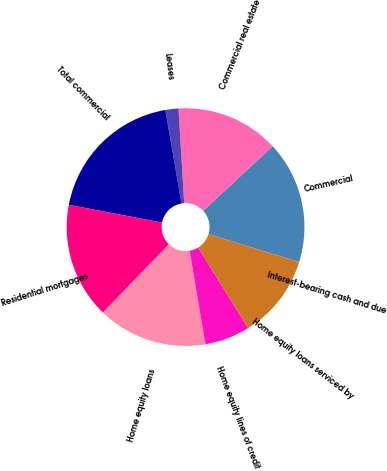<chart> <loc_0><loc_0><loc_500><loc_500><pie_chart><fcel>Interest-bearing cash and due<fcel>Commercial<fcel>Commercial real estate<fcel>Leases<fcel>Total commercial<fcel>Residential mortgages<fcel>Home equity loans<fcel>Home equity lines of credit<fcel>Home equity loans serviced by<nl><fcel>0.03%<fcel>16.65%<fcel>14.03%<fcel>1.78%<fcel>19.27%<fcel>15.78%<fcel>14.9%<fcel>6.16%<fcel>11.4%<nl></chart> 